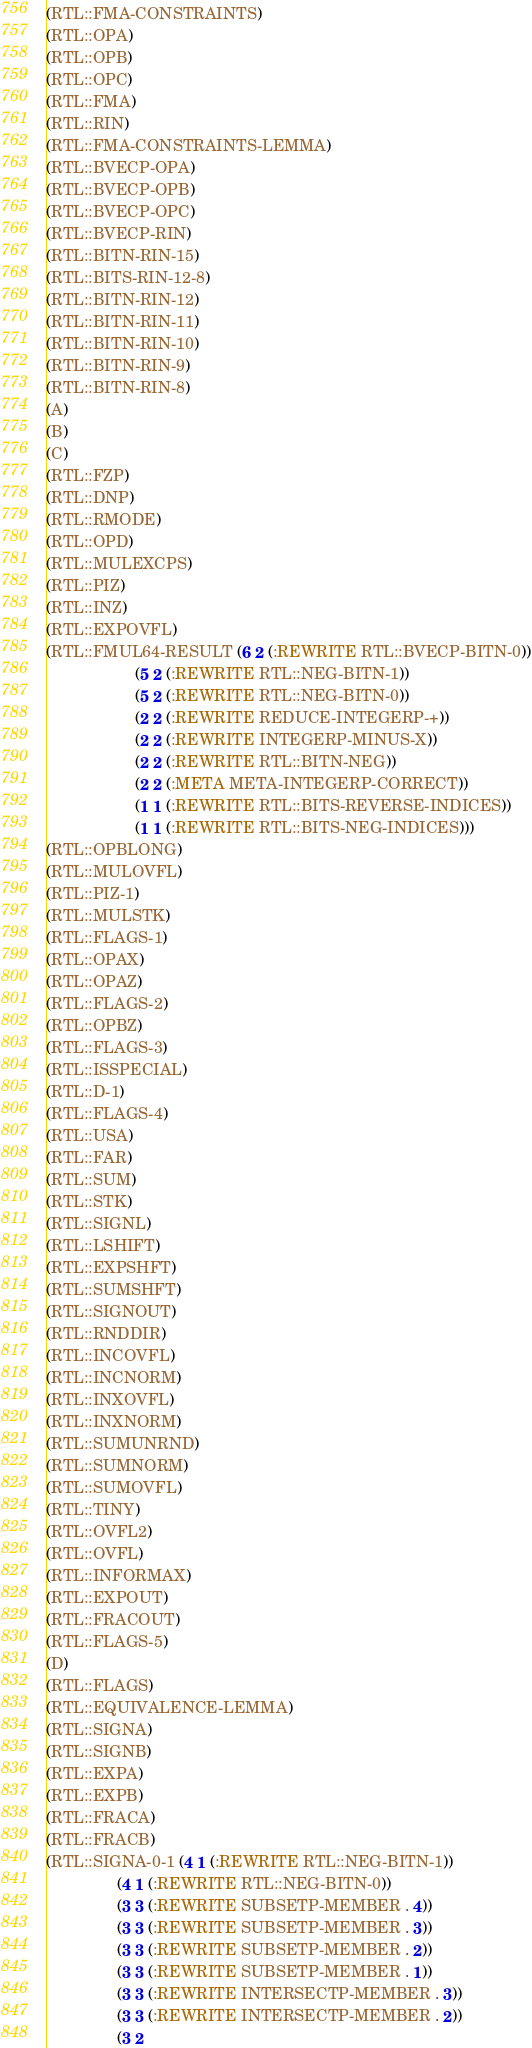<code> <loc_0><loc_0><loc_500><loc_500><_Lisp_>(RTL::FMA-CONSTRAINTS)
(RTL::OPA)
(RTL::OPB)
(RTL::OPC)
(RTL::FMA)
(RTL::RIN)
(RTL::FMA-CONSTRAINTS-LEMMA)
(RTL::BVECP-OPA)
(RTL::BVECP-OPB)
(RTL::BVECP-OPC)
(RTL::BVECP-RIN)
(RTL::BITN-RIN-15)
(RTL::BITS-RIN-12-8)
(RTL::BITN-RIN-12)
(RTL::BITN-RIN-11)
(RTL::BITN-RIN-10)
(RTL::BITN-RIN-9)
(RTL::BITN-RIN-8)
(A)
(B)
(C)
(RTL::FZP)
(RTL::DNP)
(RTL::RMODE)
(RTL::OPD)
(RTL::MULEXCPS)
(RTL::PIZ)
(RTL::INZ)
(RTL::EXPOVFL)
(RTL::FMUL64-RESULT (6 2 (:REWRITE RTL::BVECP-BITN-0))
                    (5 2 (:REWRITE RTL::NEG-BITN-1))
                    (5 2 (:REWRITE RTL::NEG-BITN-0))
                    (2 2 (:REWRITE REDUCE-INTEGERP-+))
                    (2 2 (:REWRITE INTEGERP-MINUS-X))
                    (2 2 (:REWRITE RTL::BITN-NEG))
                    (2 2 (:META META-INTEGERP-CORRECT))
                    (1 1 (:REWRITE RTL::BITS-REVERSE-INDICES))
                    (1 1 (:REWRITE RTL::BITS-NEG-INDICES)))
(RTL::OPBLONG)
(RTL::MULOVFL)
(RTL::PIZ-1)
(RTL::MULSTK)
(RTL::FLAGS-1)
(RTL::OPAX)
(RTL::OPAZ)
(RTL::FLAGS-2)
(RTL::OPBZ)
(RTL::FLAGS-3)
(RTL::ISSPECIAL)
(RTL::D-1)
(RTL::FLAGS-4)
(RTL::USA)
(RTL::FAR)
(RTL::SUM)
(RTL::STK)
(RTL::SIGNL)
(RTL::LSHIFT)
(RTL::EXPSHFT)
(RTL::SUMSHFT)
(RTL::SIGNOUT)
(RTL::RNDDIR)
(RTL::INCOVFL)
(RTL::INCNORM)
(RTL::INXOVFL)
(RTL::INXNORM)
(RTL::SUMUNRND)
(RTL::SUMNORM)
(RTL::SUMOVFL)
(RTL::TINY)
(RTL::OVFL2)
(RTL::OVFL)
(RTL::INFORMAX)
(RTL::EXPOUT)
(RTL::FRACOUT)
(RTL::FLAGS-5)
(D)
(RTL::FLAGS)
(RTL::EQUIVALENCE-LEMMA)
(RTL::SIGNA)
(RTL::SIGNB)
(RTL::EXPA)
(RTL::EXPB)
(RTL::FRACA)
(RTL::FRACB)
(RTL::SIGNA-0-1 (4 1 (:REWRITE RTL::NEG-BITN-1))
                (4 1 (:REWRITE RTL::NEG-BITN-0))
                (3 3 (:REWRITE SUBSETP-MEMBER . 4))
                (3 3 (:REWRITE SUBSETP-MEMBER . 3))
                (3 3 (:REWRITE SUBSETP-MEMBER . 2))
                (3 3 (:REWRITE SUBSETP-MEMBER . 1))
                (3 3 (:REWRITE INTERSECTP-MEMBER . 3))
                (3 3 (:REWRITE INTERSECTP-MEMBER . 2))
                (3 2</code> 